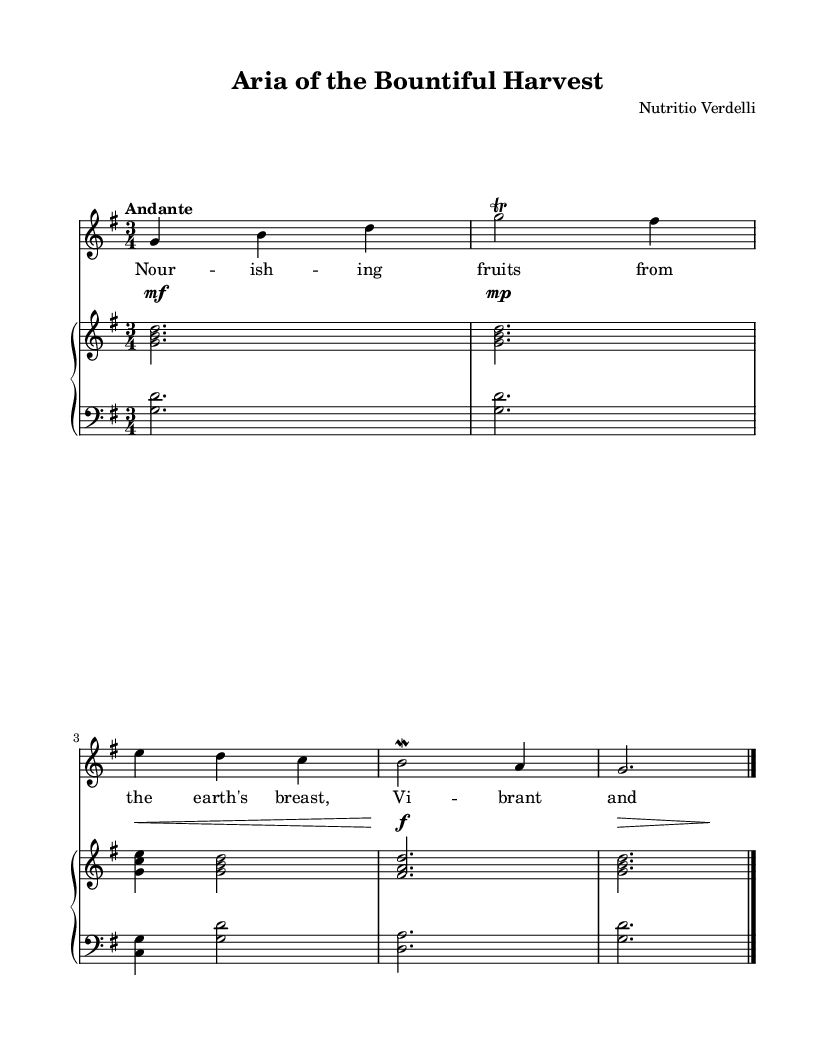What is the key signature of this music? The key signature is G major, which has one sharp (F#). This can be determined by looking at the clef and the key signature indication at the beginning of the piece.
Answer: G major What is the time signature of this piece? The time signature is 3/4, as shown at the beginning of the music, indicating there are three beats in each measure and a quarter note receives one beat.
Answer: 3/4 What is the tempo marking of this music? The tempo marking is “Andante”, which typically indicates a moderately slow tempo. This is indicated in the tempo instruction written above the staff.
Answer: Andante How many measures are in the soprano line? The soprano line contains four measures, defined by the vertical bar lines separating the groups of notes. Each measure ends with a vertical bar line.
Answer: Four Which dynamics indications are present in this music? The dynamics markings present are mezzo-forte, mezzo-piano, crescendo, and forte, which guide the performer on the loudness of the music at various points. These are indicated in the dynamics section of the score.
Answer: Mezzo-forte, mezzo-piano, crescendo, forte What are the influenced themes shown through the lyrics in this opera? The lyrics reflect themes of nourishment and the blessings of fresh fruits, indicating a connection to the culinary delights of nature. This is derived from analyzing the words sung by the soprano voice in relation to the title.
Answer: Nourishment and culinary delights What type of accompaniment is provided in this score? The accompaniment is provided by a piano, which is common in operatic compositions to support the vocal line while creating an atmospheric backdrop. The score indicates a PianoStaff with separate right and left hands.
Answer: Piano 